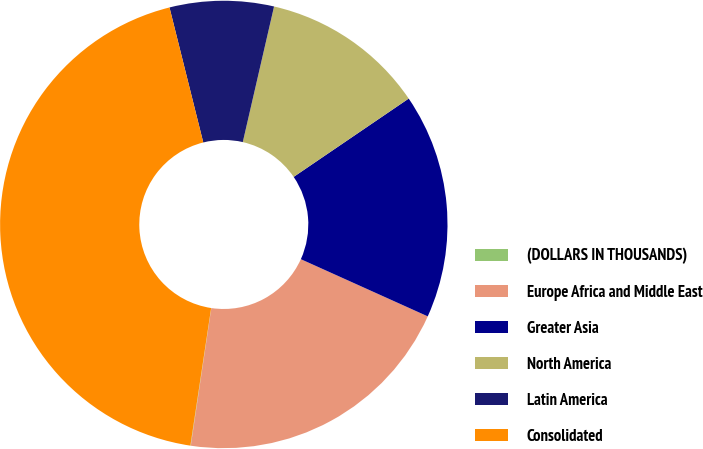Convert chart to OTSL. <chart><loc_0><loc_0><loc_500><loc_500><pie_chart><fcel>(DOLLARS IN THOUSANDS)<fcel>Europe Africa and Middle East<fcel>Greater Asia<fcel>North America<fcel>Latin America<fcel>Consolidated<nl><fcel>0.03%<fcel>20.62%<fcel>16.25%<fcel>11.88%<fcel>7.51%<fcel>43.71%<nl></chart> 